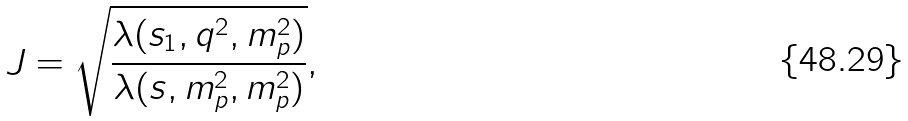<formula> <loc_0><loc_0><loc_500><loc_500>J = \sqrt { \frac { \lambda ( s _ { 1 } , q ^ { 2 } , m _ { p } ^ { 2 } ) } { \lambda ( s , m _ { p } ^ { 2 } , m _ { p } ^ { 2 } ) } } ,</formula> 